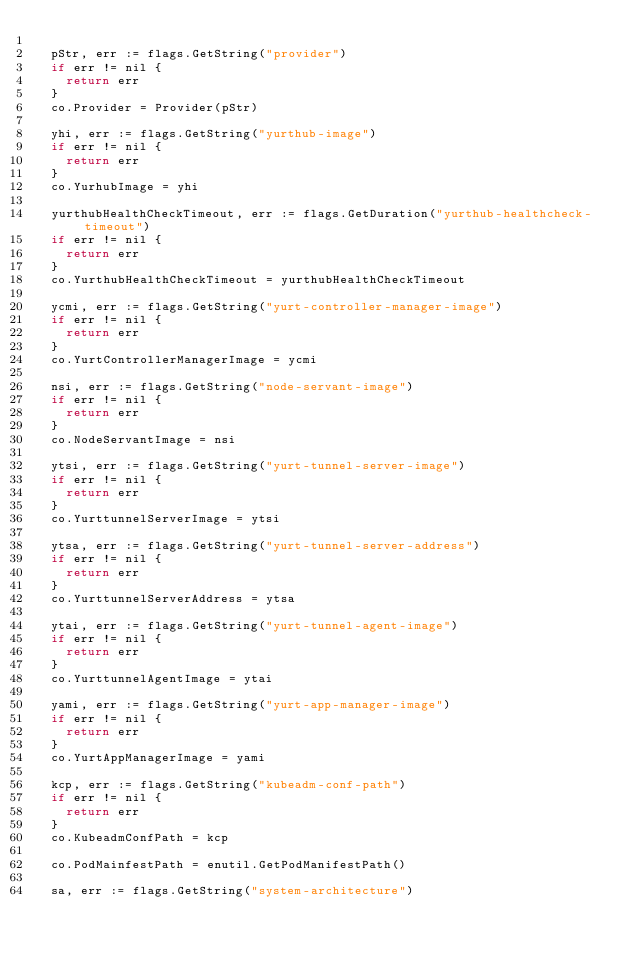<code> <loc_0><loc_0><loc_500><loc_500><_Go_>
	pStr, err := flags.GetString("provider")
	if err != nil {
		return err
	}
	co.Provider = Provider(pStr)

	yhi, err := flags.GetString("yurthub-image")
	if err != nil {
		return err
	}
	co.YurhubImage = yhi

	yurthubHealthCheckTimeout, err := flags.GetDuration("yurthub-healthcheck-timeout")
	if err != nil {
		return err
	}
	co.YurthubHealthCheckTimeout = yurthubHealthCheckTimeout

	ycmi, err := flags.GetString("yurt-controller-manager-image")
	if err != nil {
		return err
	}
	co.YurtControllerManagerImage = ycmi

	nsi, err := flags.GetString("node-servant-image")
	if err != nil {
		return err
	}
	co.NodeServantImage = nsi

	ytsi, err := flags.GetString("yurt-tunnel-server-image")
	if err != nil {
		return err
	}
	co.YurttunnelServerImage = ytsi

	ytsa, err := flags.GetString("yurt-tunnel-server-address")
	if err != nil {
		return err
	}
	co.YurttunnelServerAddress = ytsa

	ytai, err := flags.GetString("yurt-tunnel-agent-image")
	if err != nil {
		return err
	}
	co.YurttunnelAgentImage = ytai

	yami, err := flags.GetString("yurt-app-manager-image")
	if err != nil {
		return err
	}
	co.YurtAppManagerImage = yami

	kcp, err := flags.GetString("kubeadm-conf-path")
	if err != nil {
		return err
	}
	co.KubeadmConfPath = kcp

	co.PodMainfestPath = enutil.GetPodManifestPath()

	sa, err := flags.GetString("system-architecture")</code> 